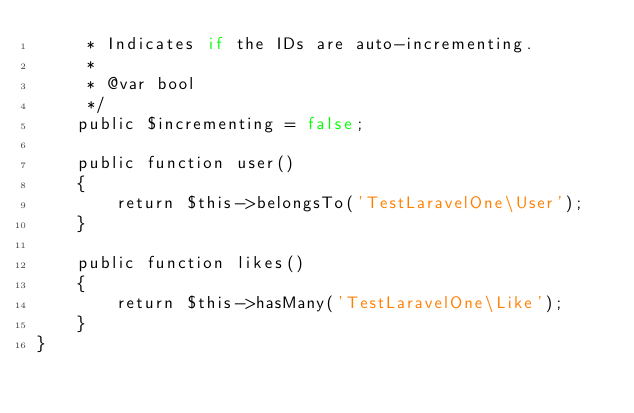Convert code to text. <code><loc_0><loc_0><loc_500><loc_500><_PHP_>     * Indicates if the IDs are auto-incrementing.
     *
     * @var bool
     */
    public $incrementing = false;

    public function user()
    {
        return $this->belongsTo('TestLaravelOne\User');
    }

    public function likes()
    {
        return $this->hasMany('TestLaravelOne\Like');
    }
}
</code> 